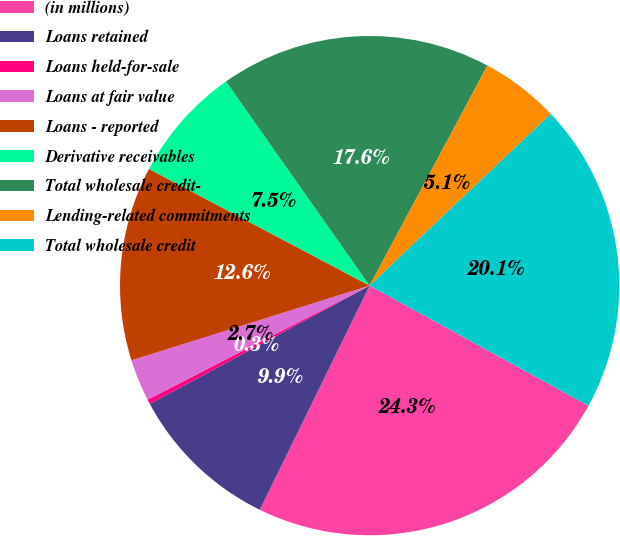Convert chart to OTSL. <chart><loc_0><loc_0><loc_500><loc_500><pie_chart><fcel>(in millions)<fcel>Loans retained<fcel>Loans held-for-sale<fcel>Loans at fair value<fcel>Loans - reported<fcel>Derivative receivables<fcel>Total wholesale credit-<fcel>Lending-related commitments<fcel>Total wholesale credit<nl><fcel>24.26%<fcel>9.89%<fcel>0.31%<fcel>2.71%<fcel>12.58%<fcel>7.5%<fcel>17.58%<fcel>5.1%<fcel>20.06%<nl></chart> 